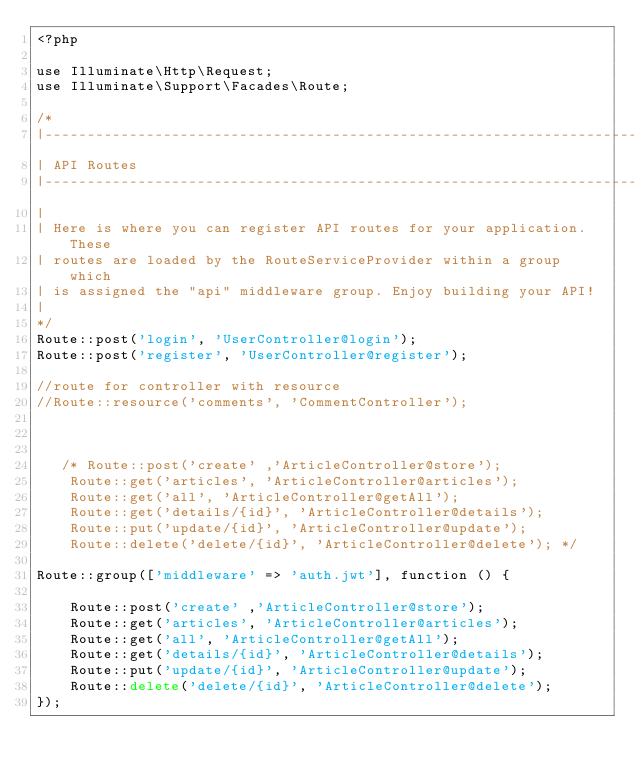Convert code to text. <code><loc_0><loc_0><loc_500><loc_500><_PHP_><?php

use Illuminate\Http\Request;
use Illuminate\Support\Facades\Route;

/*
|--------------------------------------------------------------------------
| API Routes
|--------------------------------------------------------------------------
|
| Here is where you can register API routes for your application. These
| routes are loaded by the RouteServiceProvider within a group which
| is assigned the "api" middleware group. Enjoy building your API!
|
*/
Route::post('login', 'UserController@login');
Route::post('register', 'UserController@register');

//route for controller with resource
//Route::resource('comments', 'CommentController');



   /* Route::post('create' ,'ArticleController@store');
    Route::get('articles', 'ArticleController@articles');
    Route::get('all', 'ArticleController@getAll');
    Route::get('details/{id}', 'ArticleController@details');
    Route::put('update/{id}', 'ArticleController@update');
    Route::delete('delete/{id}', 'ArticleController@delete'); */
    
Route::group(['middleware' => 'auth.jwt'], function () { 

    Route::post('create' ,'ArticleController@store');
    Route::get('articles', 'ArticleController@articles');
    Route::get('all', 'ArticleController@getAll');
    Route::get('details/{id}', 'ArticleController@details');
    Route::put('update/{id}', 'ArticleController@update');
    Route::delete('delete/{id}', 'ArticleController@delete');
});
</code> 